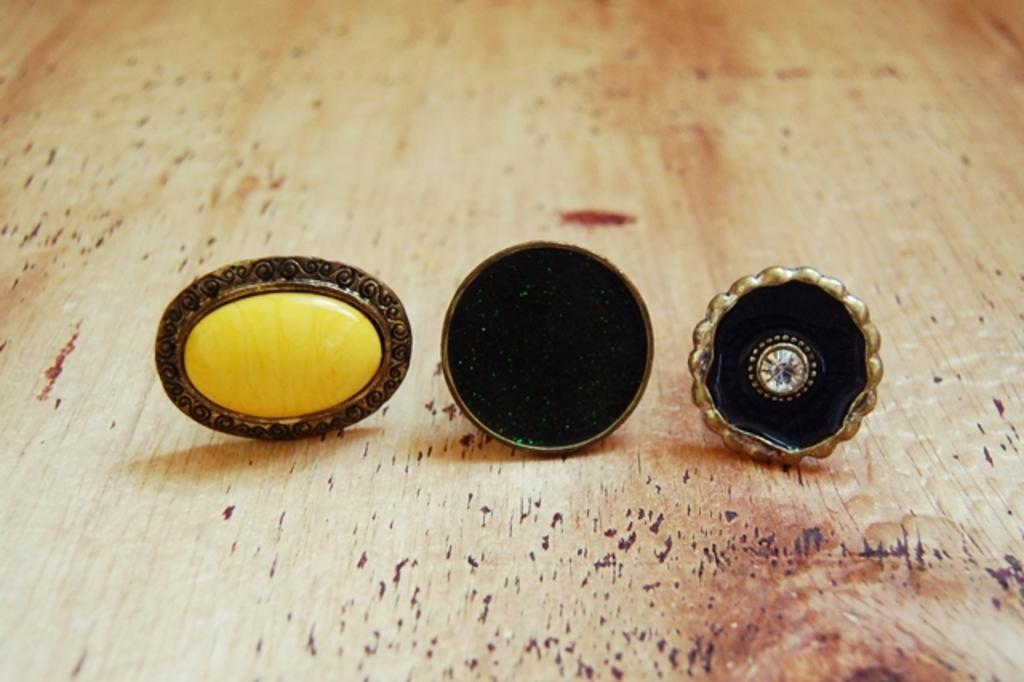How many types of objects are in the image? There are three different types of objects in the image. What is the nature of these objects? The objects look like jewelry. Where are these objects located in the image? The objects are placed on a surface. What type of farm animals can be seen in the image? There are no farm animals present in the image. How does the lift function in the image? There is no lift present in the image. 